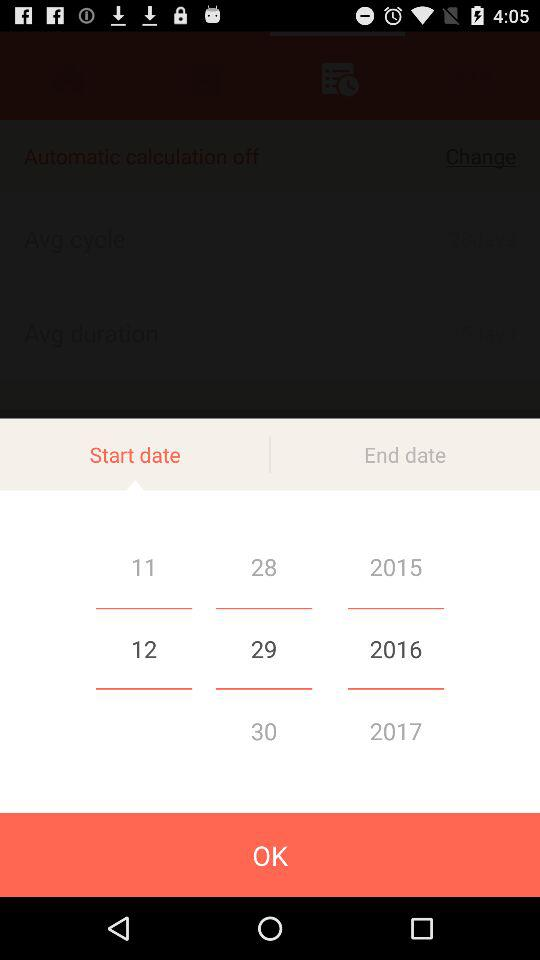What is the selected start date? The selected start date is December 29, 2016. 